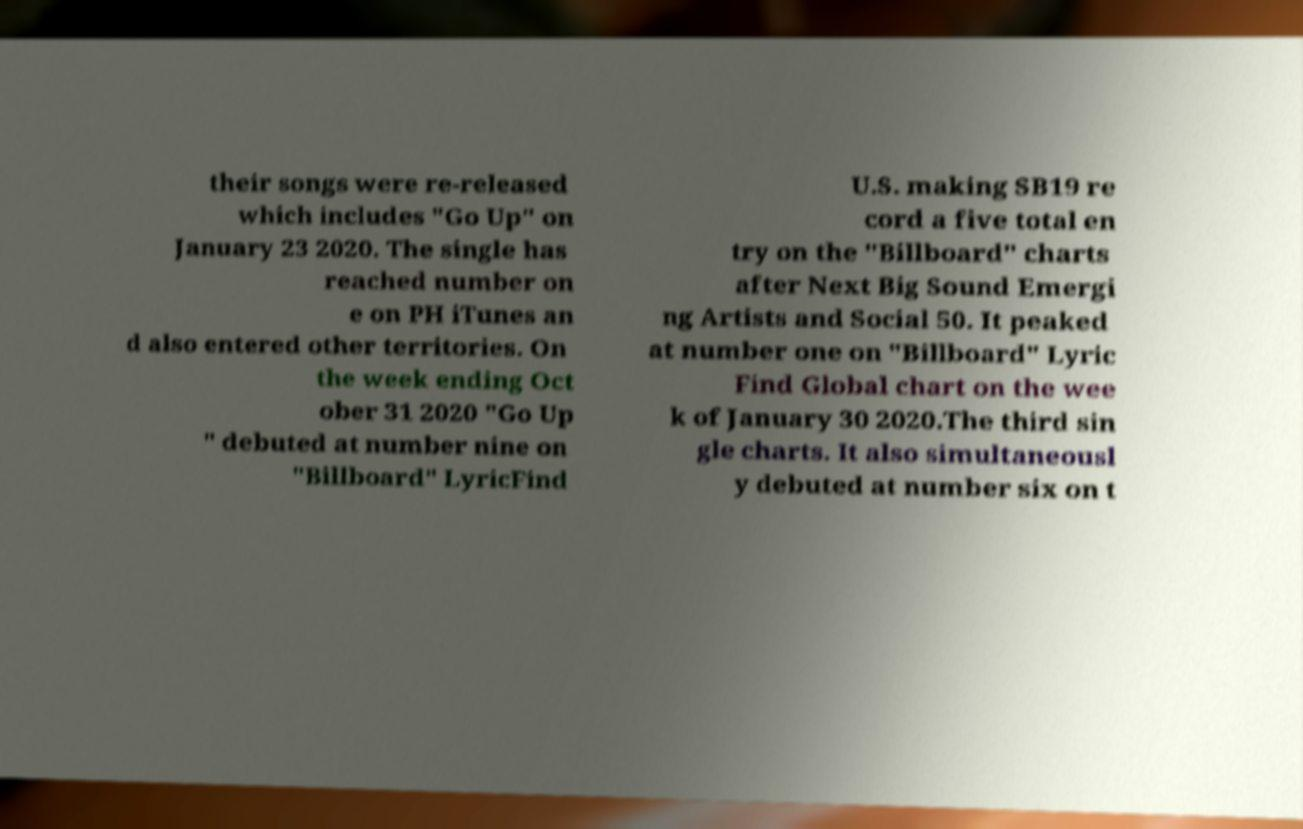Could you assist in decoding the text presented in this image and type it out clearly? their songs were re-released which includes "Go Up" on January 23 2020. The single has reached number on e on PH iTunes an d also entered other territories. On the week ending Oct ober 31 2020 "Go Up " debuted at number nine on "Billboard" LyricFind U.S. making SB19 re cord a five total en try on the "Billboard" charts after Next Big Sound Emergi ng Artists and Social 50. It peaked at number one on "Billboard" Lyric Find Global chart on the wee k of January 30 2020.The third sin gle charts. It also simultaneousl y debuted at number six on t 